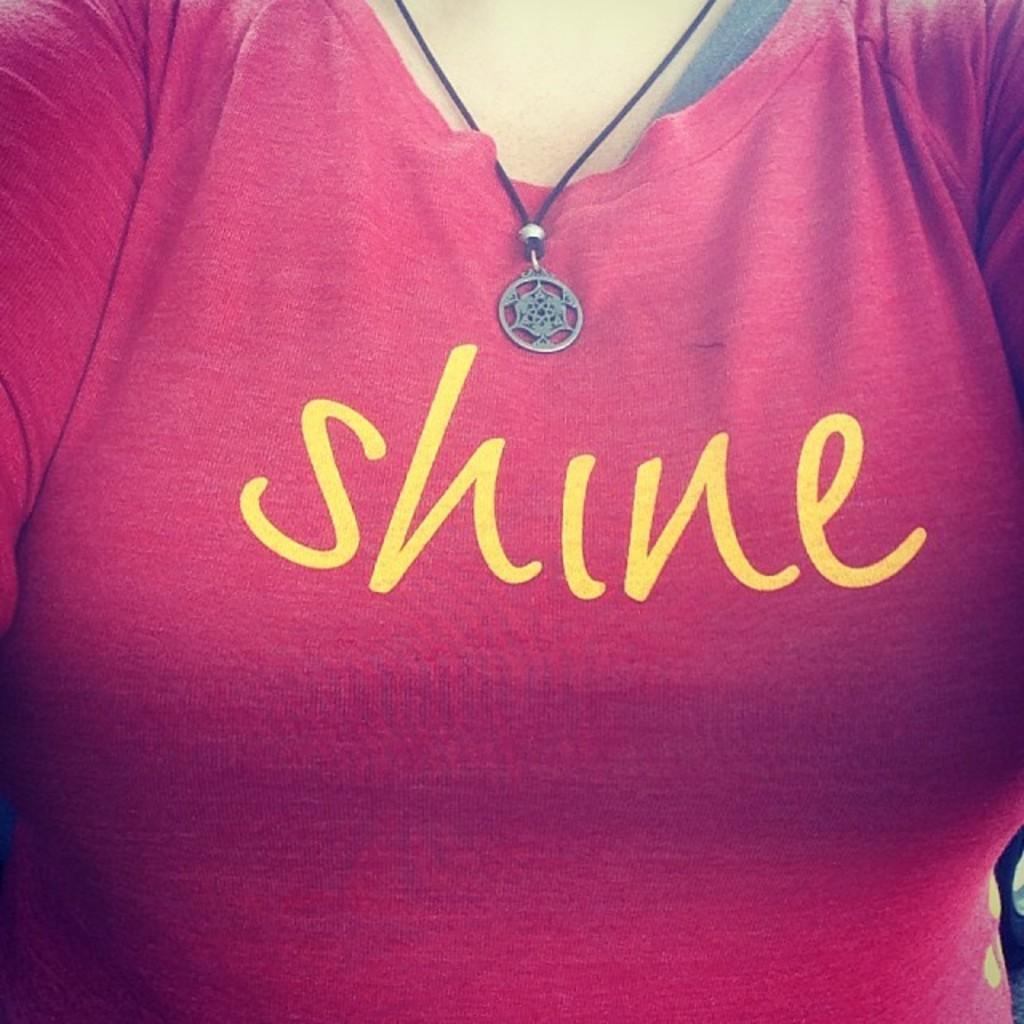In one or two sentences, can you explain what this image depicts? In the image we can see a person wearing clothes, neck chain and there is a text on the clothes. 